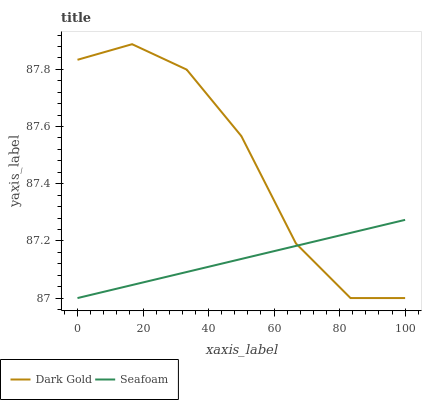Does Seafoam have the minimum area under the curve?
Answer yes or no. Yes. Does Dark Gold have the maximum area under the curve?
Answer yes or no. Yes. Does Dark Gold have the minimum area under the curve?
Answer yes or no. No. Is Seafoam the smoothest?
Answer yes or no. Yes. Is Dark Gold the roughest?
Answer yes or no. Yes. Is Dark Gold the smoothest?
Answer yes or no. No. Does Seafoam have the lowest value?
Answer yes or no. Yes. Does Dark Gold have the highest value?
Answer yes or no. Yes. Does Seafoam intersect Dark Gold?
Answer yes or no. Yes. Is Seafoam less than Dark Gold?
Answer yes or no. No. Is Seafoam greater than Dark Gold?
Answer yes or no. No. 